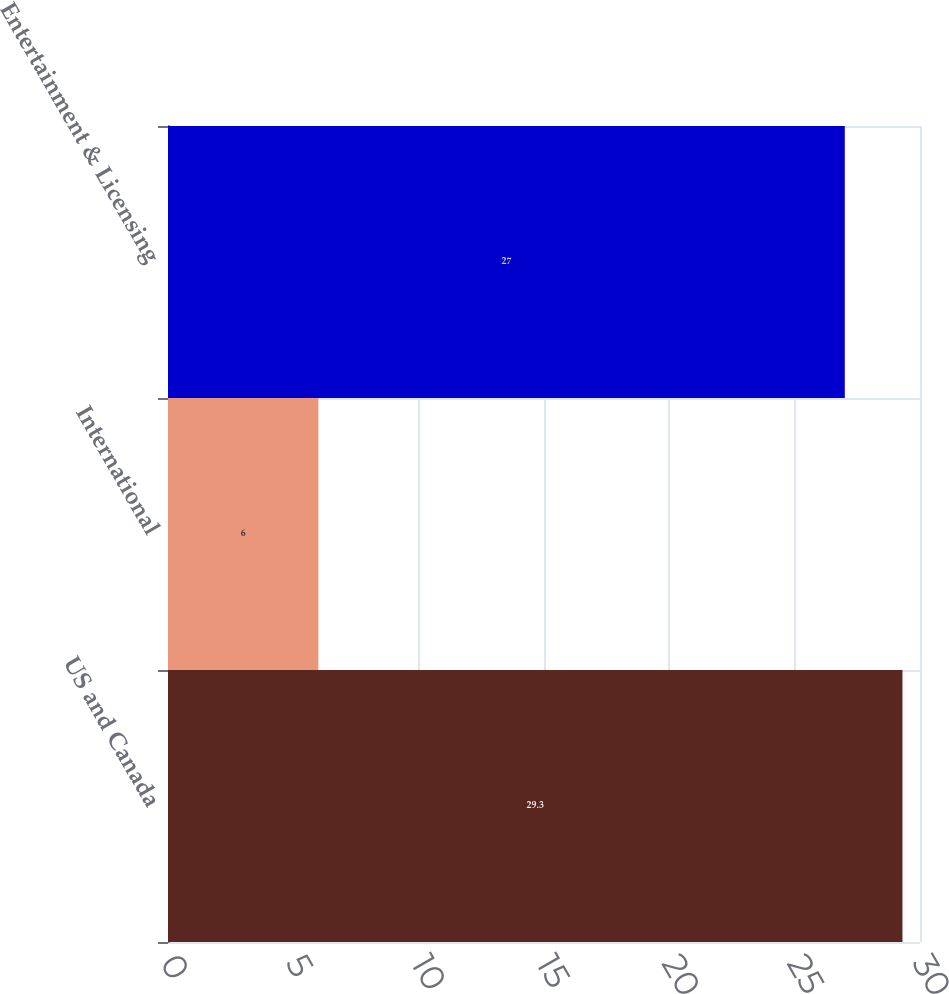Convert chart to OTSL. <chart><loc_0><loc_0><loc_500><loc_500><bar_chart><fcel>US and Canada<fcel>International<fcel>Entertainment & Licensing<nl><fcel>29.3<fcel>6<fcel>27<nl></chart> 